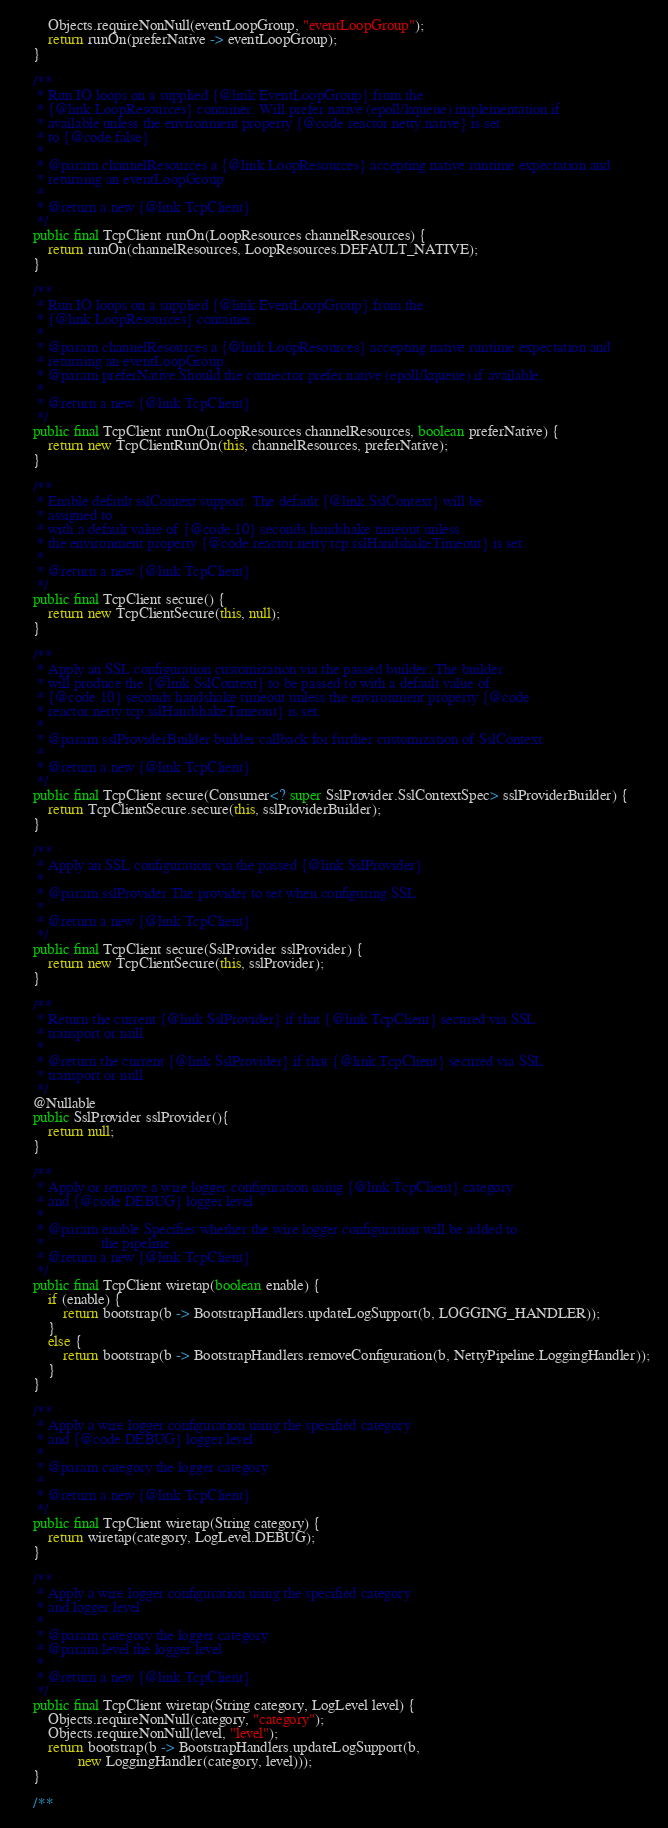<code> <loc_0><loc_0><loc_500><loc_500><_Java_>		Objects.requireNonNull(eventLoopGroup, "eventLoopGroup");
		return runOn(preferNative -> eventLoopGroup);
	}

	/**
	 * Run IO loops on a supplied {@link EventLoopGroup} from the
	 * {@link LoopResources} container. Will prefer native (epoll/kqueue) implementation if
	 * available unless the environment property {@code reactor.netty.native} is set
	 * to {@code false}.
	 *
	 * @param channelResources a {@link LoopResources} accepting native runtime expectation and
	 * returning an eventLoopGroup
	 *
	 * @return a new {@link TcpClient}
	 */
	public final TcpClient runOn(LoopResources channelResources) {
		return runOn(channelResources, LoopResources.DEFAULT_NATIVE);
	}

	/**
	 * Run IO loops on a supplied {@link EventLoopGroup} from the
	 * {@link LoopResources} container.
	 *
	 * @param channelResources a {@link LoopResources} accepting native runtime expectation and
	 * returning an eventLoopGroup.
	 * @param preferNative Should the connector prefer native (epoll/kqueue) if available.
	 *
	 * @return a new {@link TcpClient}
	 */
	public final TcpClient runOn(LoopResources channelResources, boolean preferNative) {
		return new TcpClientRunOn(this, channelResources, preferNative);
	}

	/**
	 * Enable default sslContext support. The default {@link SslContext} will be
	 * assigned to
	 * with a default value of {@code 10} seconds handshake timeout unless
	 * the environment property {@code reactor.netty.tcp.sslHandshakeTimeout} is set.
	 *
	 * @return a new {@link TcpClient}
	 */
	public final TcpClient secure() {
		return new TcpClientSecure(this, null);
	}

	/**
	 * Apply an SSL configuration customization via the passed builder. The builder
	 * will produce the {@link SslContext} to be passed to with a default value of
	 * {@code 10} seconds handshake timeout unless the environment property {@code
	 * reactor.netty.tcp.sslHandshakeTimeout} is set.
	 *
	 * @param sslProviderBuilder builder callback for further customization of SslContext.
	 *
	 * @return a new {@link TcpClient}
	 */
	public final TcpClient secure(Consumer<? super SslProvider.SslContextSpec> sslProviderBuilder) {
		return TcpClientSecure.secure(this, sslProviderBuilder);
	}

	/**
	 * Apply an SSL configuration via the passed {@link SslProvider}.
	 *
	 * @param sslProvider The provider to set when configuring SSL
	 *
	 * @return a new {@link TcpClient}
	 */
	public final TcpClient secure(SslProvider sslProvider) {
		return new TcpClientSecure(this, sslProvider);
	}

	/**
	 * Return the current {@link SslProvider} if that {@link TcpClient} secured via SSL
	 * transport or null
	 *
	 * @return the current {@link SslProvider} if that {@link TcpClient} secured via SSL
	 * transport or null
	 */
	@Nullable
	public SslProvider sslProvider(){
		return null;
	}

	/**
	 * Apply or remove a wire logger configuration using {@link TcpClient} category
	 * and {@code DEBUG} logger level
	 *
	 * @param enable Specifies whether the wire logger configuration will be added to
	 *               the pipeline
	 * @return a new {@link TcpClient}
	 */
	public final TcpClient wiretap(boolean enable) {
		if (enable) {
			return bootstrap(b -> BootstrapHandlers.updateLogSupport(b, LOGGING_HANDLER));
		}
		else {
			return bootstrap(b -> BootstrapHandlers.removeConfiguration(b, NettyPipeline.LoggingHandler));
		}
	}

	/**
	 * Apply a wire logger configuration using the specified category
	 * and {@code DEBUG} logger level
	 *
	 * @param category the logger category
	 *
	 * @return a new {@link TcpClient}
	 */
	public final TcpClient wiretap(String category) {
		return wiretap(category, LogLevel.DEBUG);
	}

	/**
	 * Apply a wire logger configuration using the specified category
	 * and logger level
	 *
	 * @param category the logger category
	 * @param level the logger level
	 *
	 * @return a new {@link TcpClient}
	 */
	public final TcpClient wiretap(String category, LogLevel level) {
		Objects.requireNonNull(category, "category");
		Objects.requireNonNull(level, "level");
		return bootstrap(b -> BootstrapHandlers.updateLogSupport(b,
				new LoggingHandler(category, level)));
	}

	/**</code> 